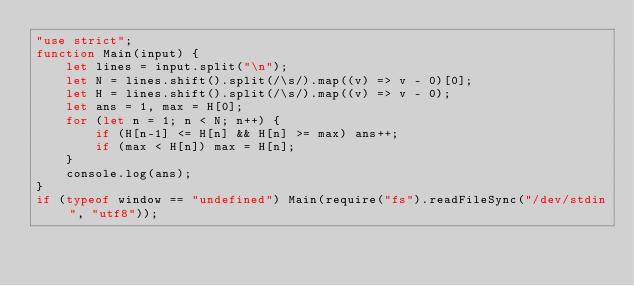Convert code to text. <code><loc_0><loc_0><loc_500><loc_500><_JavaScript_>"use strict";
function Main(input) {
    let lines = input.split("\n");
    let N = lines.shift().split(/\s/).map((v) => v - 0)[0];
    let H = lines.shift().split(/\s/).map((v) => v - 0);
    let ans = 1, max = H[0];
    for (let n = 1; n < N; n++) {
        if (H[n-1] <= H[n] && H[n] >= max) ans++;
        if (max < H[n]) max = H[n];
    }
    console.log(ans);
}
if (typeof window == "undefined") Main(require("fs").readFileSync("/dev/stdin", "utf8"));</code> 